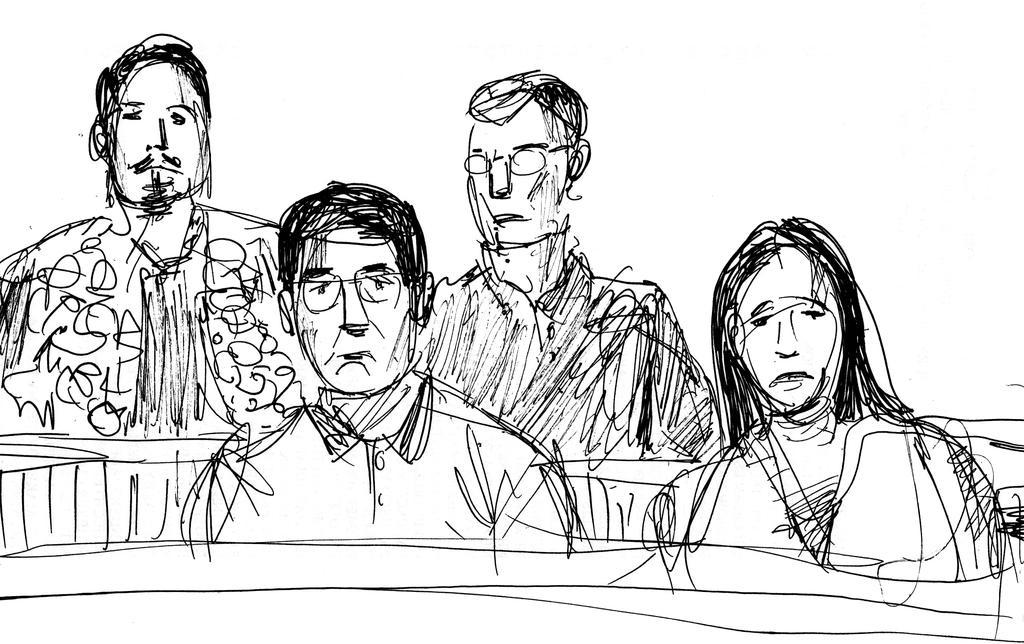In one or two sentences, can you explain what this image depicts? This is a drawing. In this drawing we can see there are three persons and a woman. 